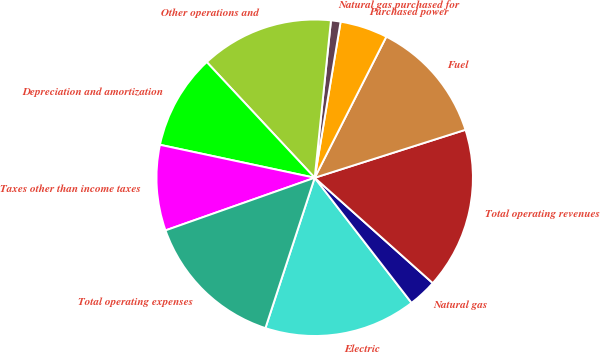Convert chart. <chart><loc_0><loc_0><loc_500><loc_500><pie_chart><fcel>Electric<fcel>Natural gas<fcel>Total operating revenues<fcel>Fuel<fcel>Purchased power<fcel>Natural gas purchased for<fcel>Other operations and<fcel>Depreciation and amortization<fcel>Taxes other than income taxes<fcel>Total operating expenses<nl><fcel>15.53%<fcel>2.92%<fcel>16.5%<fcel>12.62%<fcel>4.86%<fcel>0.98%<fcel>13.59%<fcel>9.71%<fcel>8.74%<fcel>14.56%<nl></chart> 